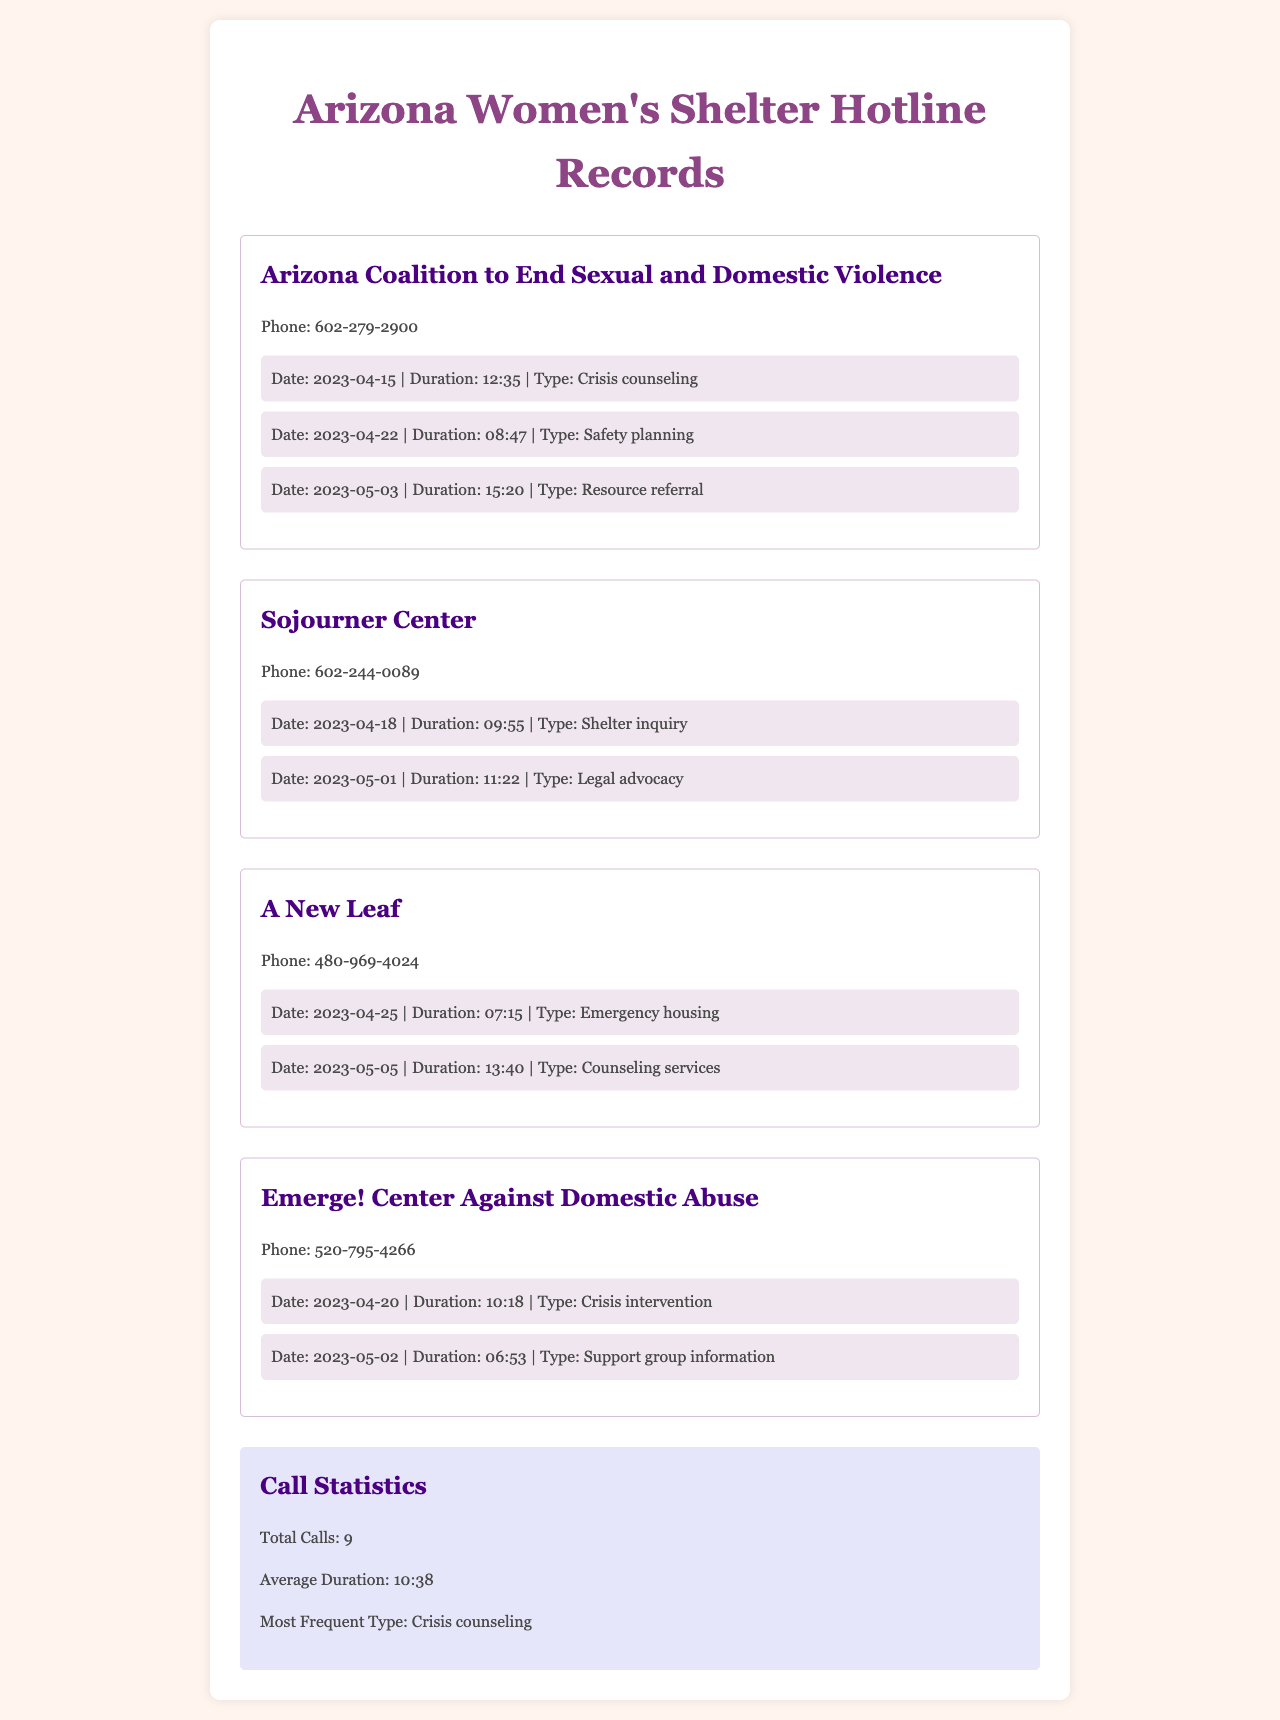What is the phone number for the Arizona Coalition to End Sexual and Domestic Violence? The phone number is listed in the hotline section of the document.
Answer: 602-279-2900 What type of service was provided during the call on April 15, 2023? The type of service is mentioned alongside the date in the call list.
Answer: Crisis counseling How many calls were made to A New Leaf? The number of calls can be determined by counting the entries in the A New Leaf section.
Answer: 2 What is the average duration of all calls made? The average duration is provided in the statistics section of the document.
Answer: 10:38 Which hotline had the most calls about crisis counseling? The type of service and its frequency are detailed in the call logs, particularly in the statistics section.
Answer: Arizona Coalition to End Sexual and Domestic Violence What was the duration of the call made on May 5, 2023, to A New Leaf? The duration is noted next to the date in the call list for A New Leaf.
Answer: 13:40 Which hotline had a call related to legal advocacy? This information can be found in the specific hotline call entries in the document.
Answer: Sojourner Center How many total calls were recorded in the document? The total number of calls is summarized in the statistics section.
Answer: 9 